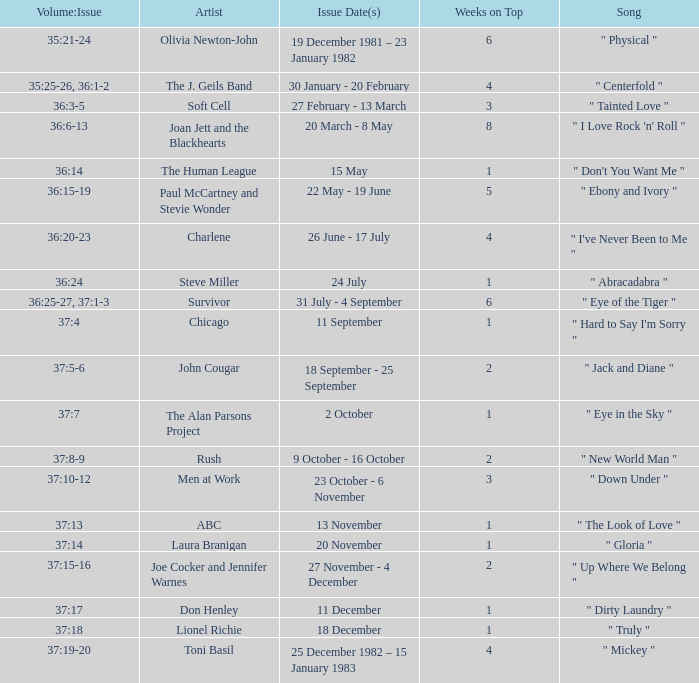Which Issue Date(s) has Weeks on Top larger than 3, and a Volume: Issue of 35:25-26, 36:1-2? 30 January - 20 February. 